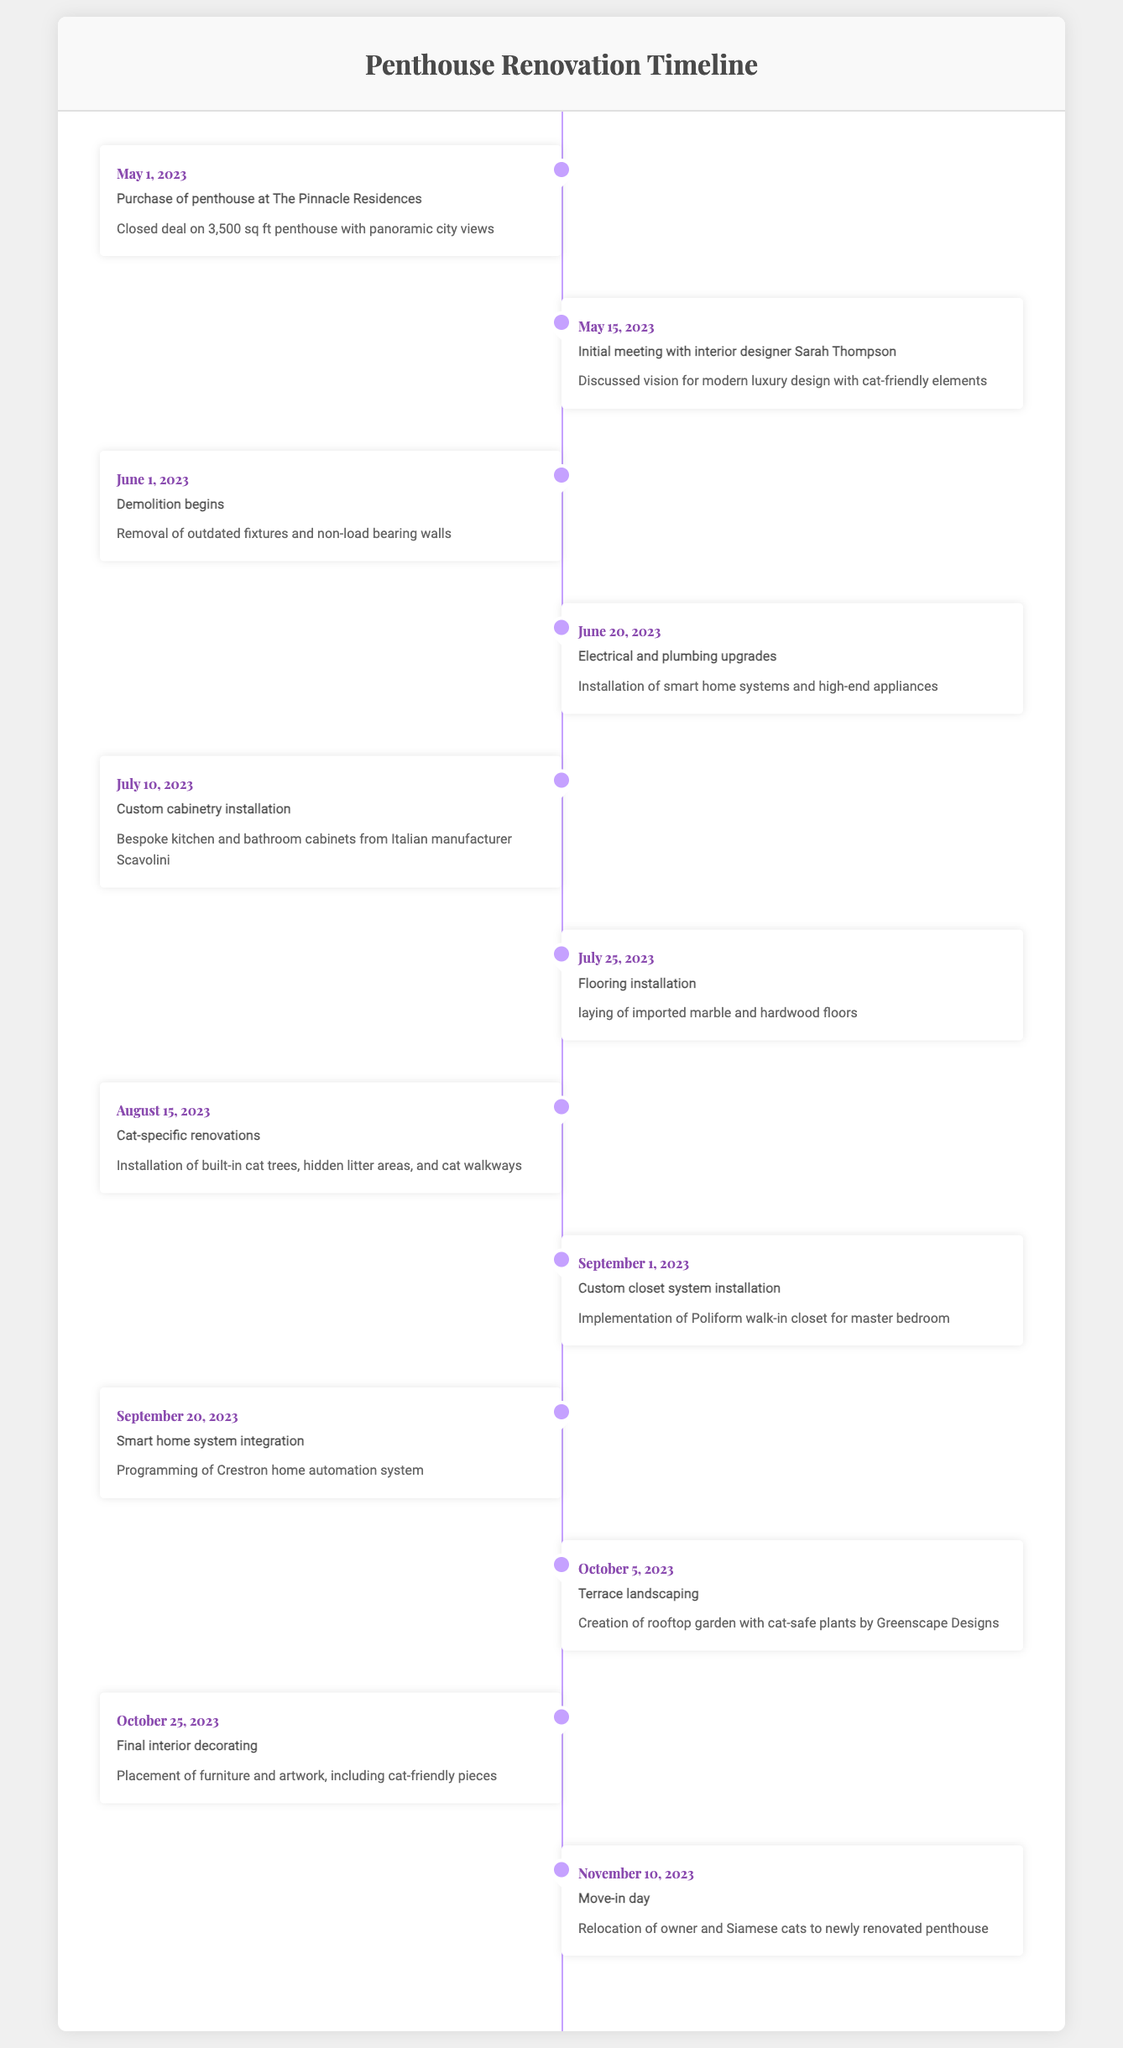What was the first milestone in the timeline? The first milestone listed in the timeline is "Purchase of penthouse at The Pinnacle Residences," which occurred on May 1, 2023.
Answer: Purchase of penthouse at The Pinnacle Residences When did the cat-specific renovations take place? The cat-specific renovations were completed on August 15, 2023, as indicated in the timeline.
Answer: August 15, 2023 How many days are there between the final interior decorating and the move-in day? The final interior decorating took place on October 25, 2023, and the move-in day was November 10, 2023. To find the number of days between these two dates, you calculate: November 10 minus October 25 equals 16 days.
Answer: 16 days Did the timeline include any milestones related to smart home systems? Yes, there are two milestones related to smart home systems: "Electrical and plumbing upgrades" on June 20, 2023, and "Smart home system integration" on September 20, 2023.
Answer: Yes What was the last renovation activity before the move-in day? The last renovation activity listed prior to the move-in day was "Final interior decorating," which occurred on October 25, 2023. This is the immediate task before relocation.
Answer: Final interior decorating How many total milestones are mentioned in the timeline? The timeline lists a total of 12 milestones from the purchase of the penthouse to the move-in day.
Answer: 12 milestones Which renovation involved a custom closet system? The milestone "Custom closet system installation" refers to the closet renovation and was completed on September 1, 2023, in the timeline.
Answer: Custom closet system installation What is the most recent milestone in the timeline? The most recent milestone in the timeline is "Move-in day," which took place on November 10, 2023, the final step of the renovation process.
Answer: Move-in day 